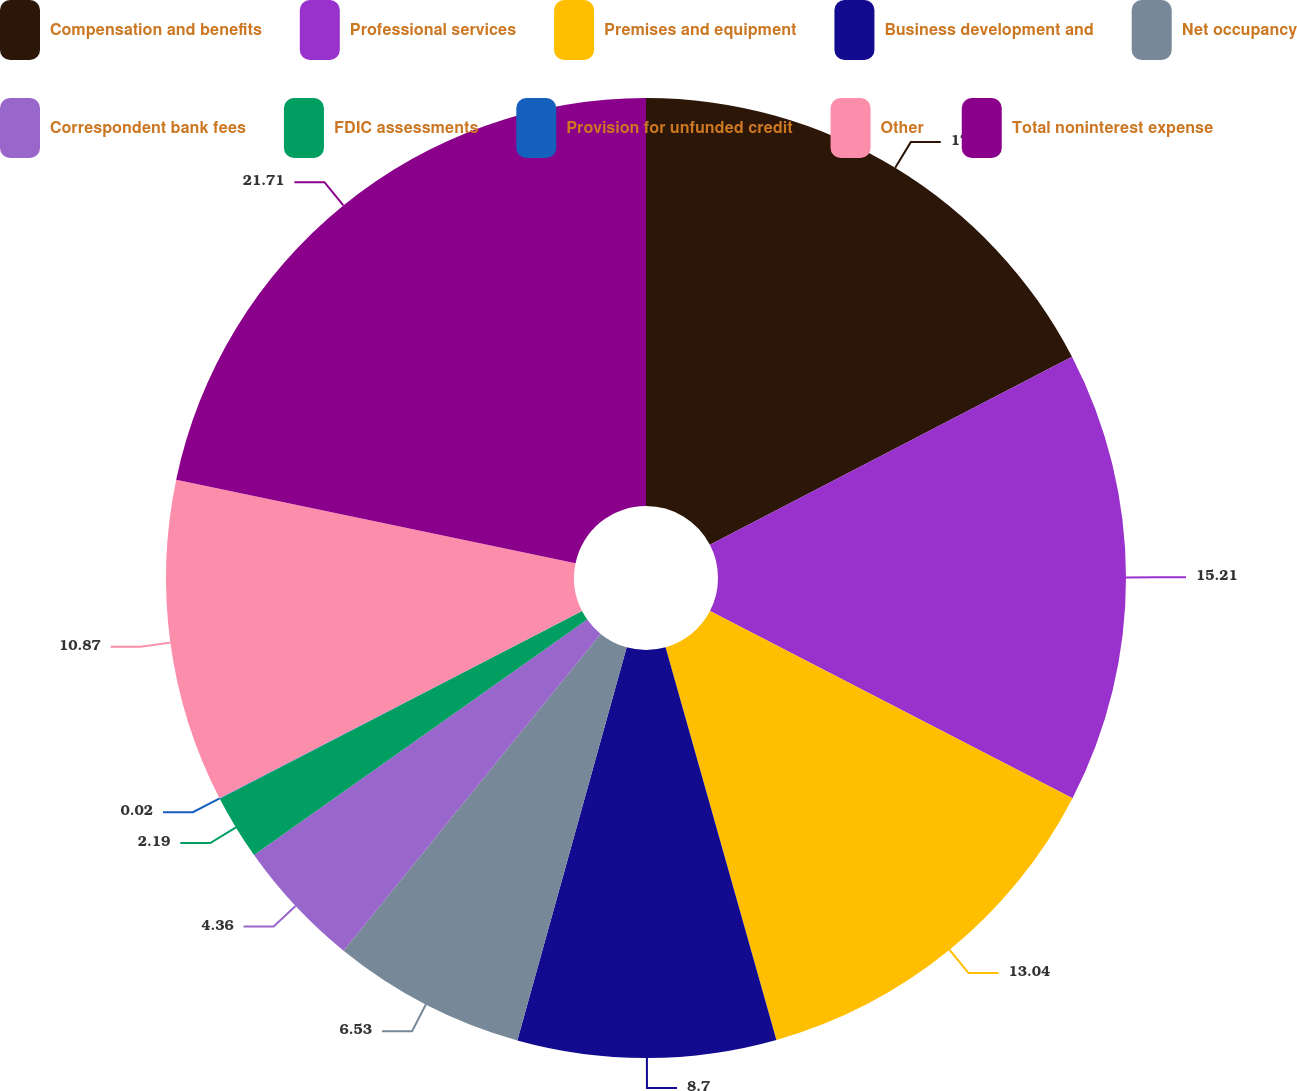Convert chart. <chart><loc_0><loc_0><loc_500><loc_500><pie_chart><fcel>Compensation and benefits<fcel>Professional services<fcel>Premises and equipment<fcel>Business development and<fcel>Net occupancy<fcel>Correspondent bank fees<fcel>FDIC assessments<fcel>Provision for unfunded credit<fcel>Other<fcel>Total noninterest expense<nl><fcel>17.38%<fcel>15.21%<fcel>13.04%<fcel>8.7%<fcel>6.53%<fcel>4.36%<fcel>2.19%<fcel>0.02%<fcel>10.87%<fcel>21.72%<nl></chart> 